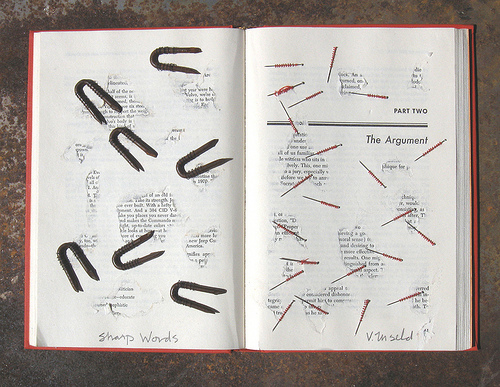<image>
Is there a pin under the book? No. The pin is not positioned under the book. The vertical relationship between these objects is different. Is there a staples on the book? Yes. Looking at the image, I can see the staples is positioned on top of the book, with the book providing support. 